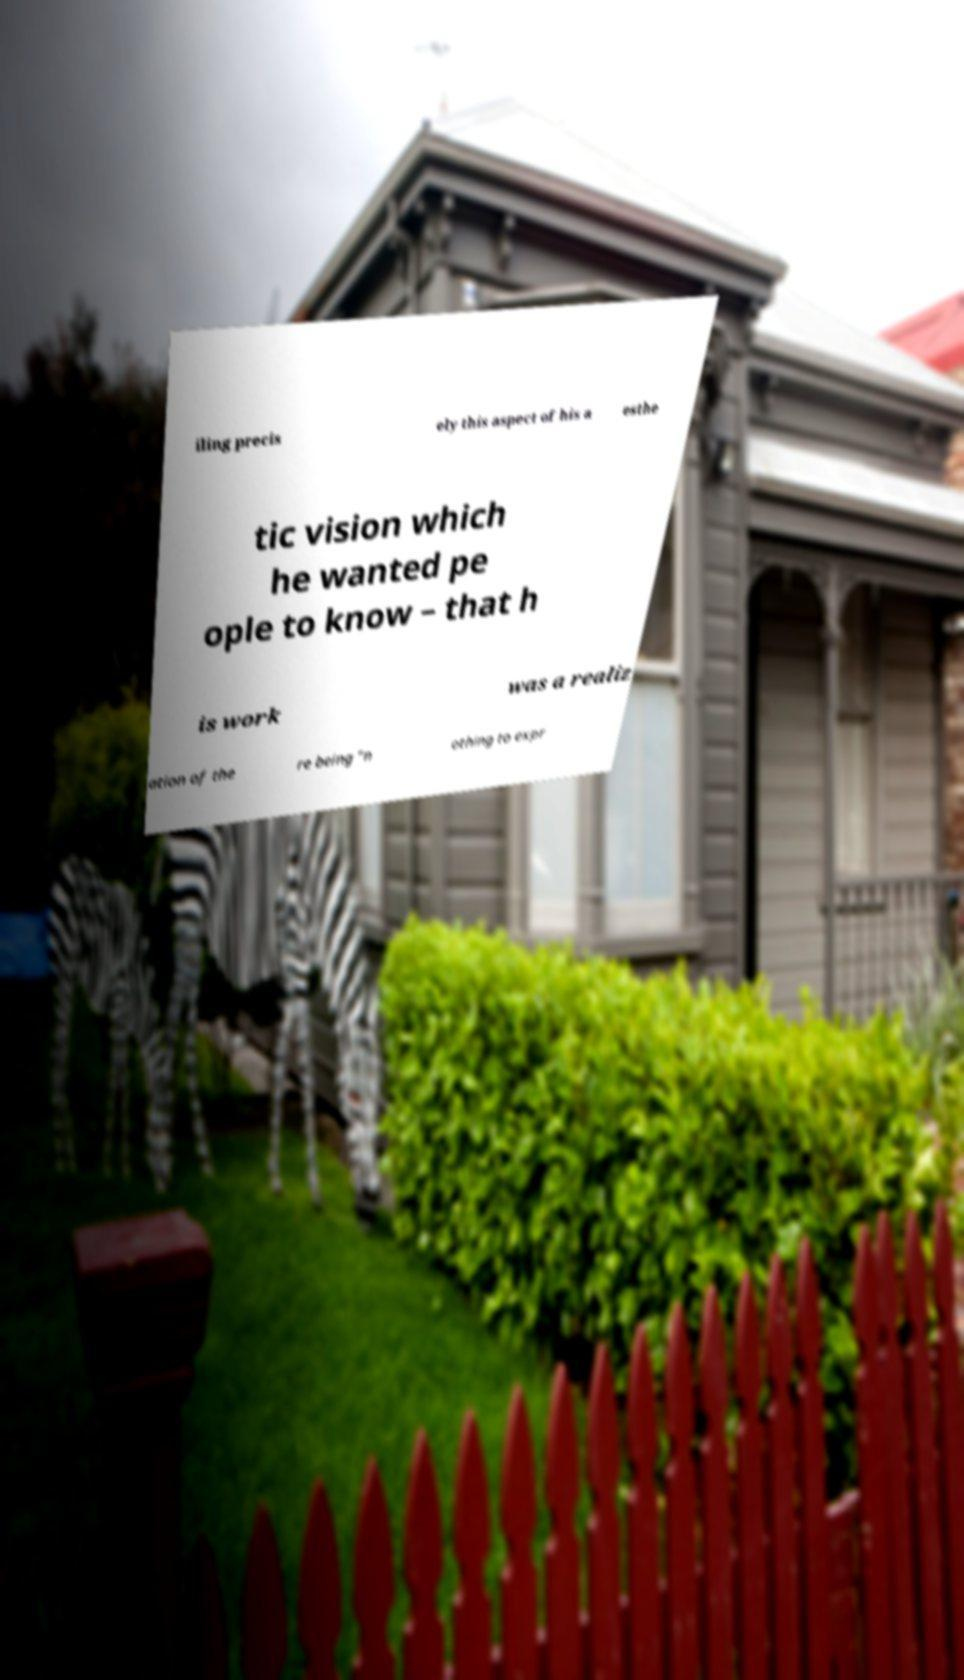Please identify and transcribe the text found in this image. iling precis ely this aspect of his a esthe tic vision which he wanted pe ople to know – that h is work was a realiz ation of the re being “n othing to expr 